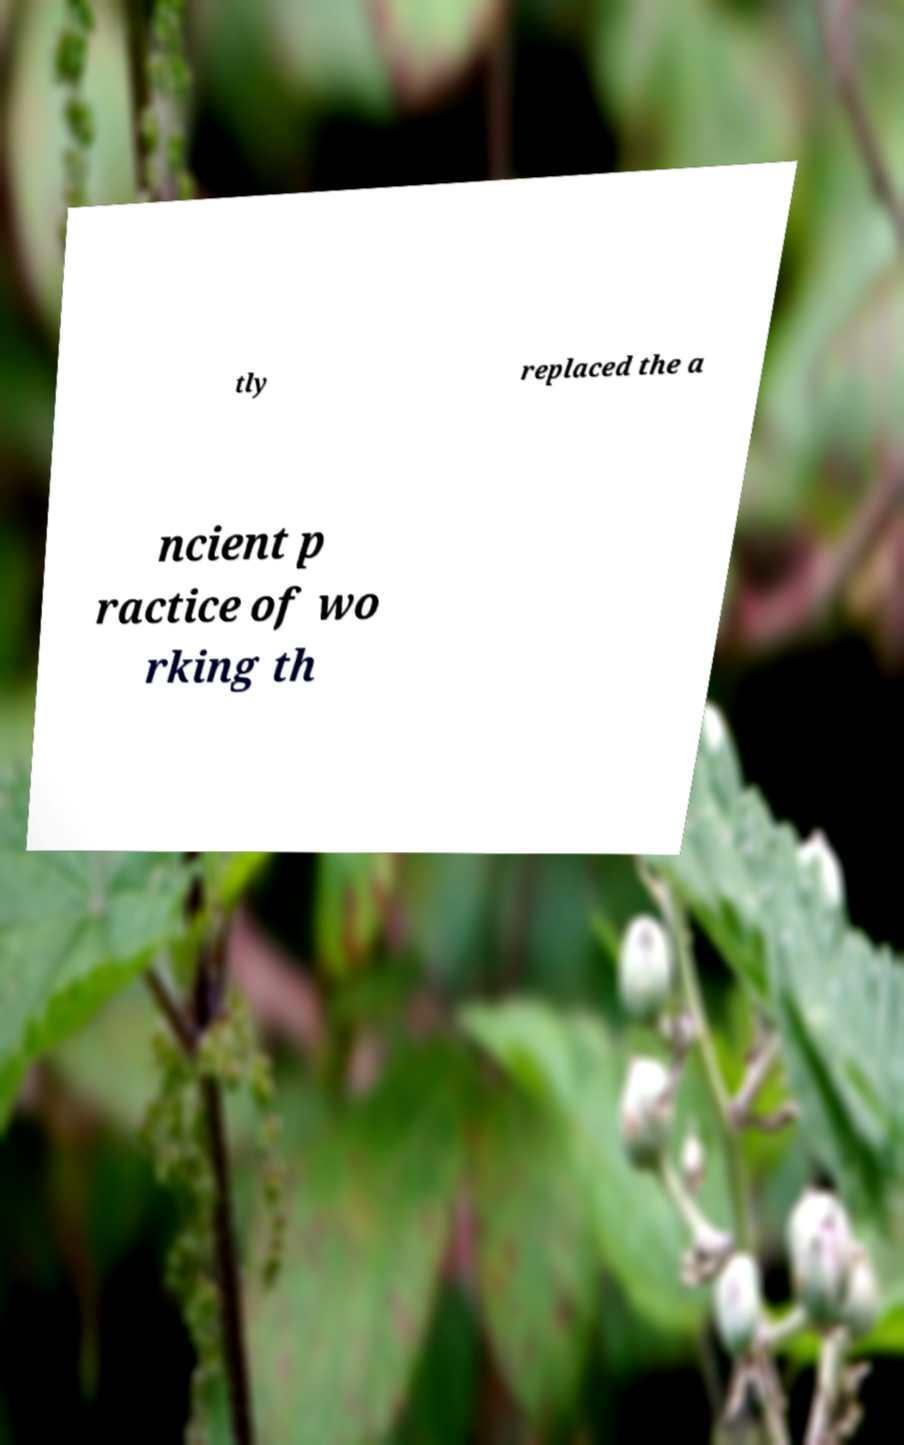I need the written content from this picture converted into text. Can you do that? tly replaced the a ncient p ractice of wo rking th 